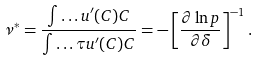<formula> <loc_0><loc_0><loc_500><loc_500>\nu ^ { * } = \frac { \int \dots u ^ { \prime } ( C ) C } { \int \dots \tau u ^ { \prime } ( C ) C } = - \left [ \frac { \partial \ln p } { \partial \delta } \right ] ^ { - 1 } .</formula> 